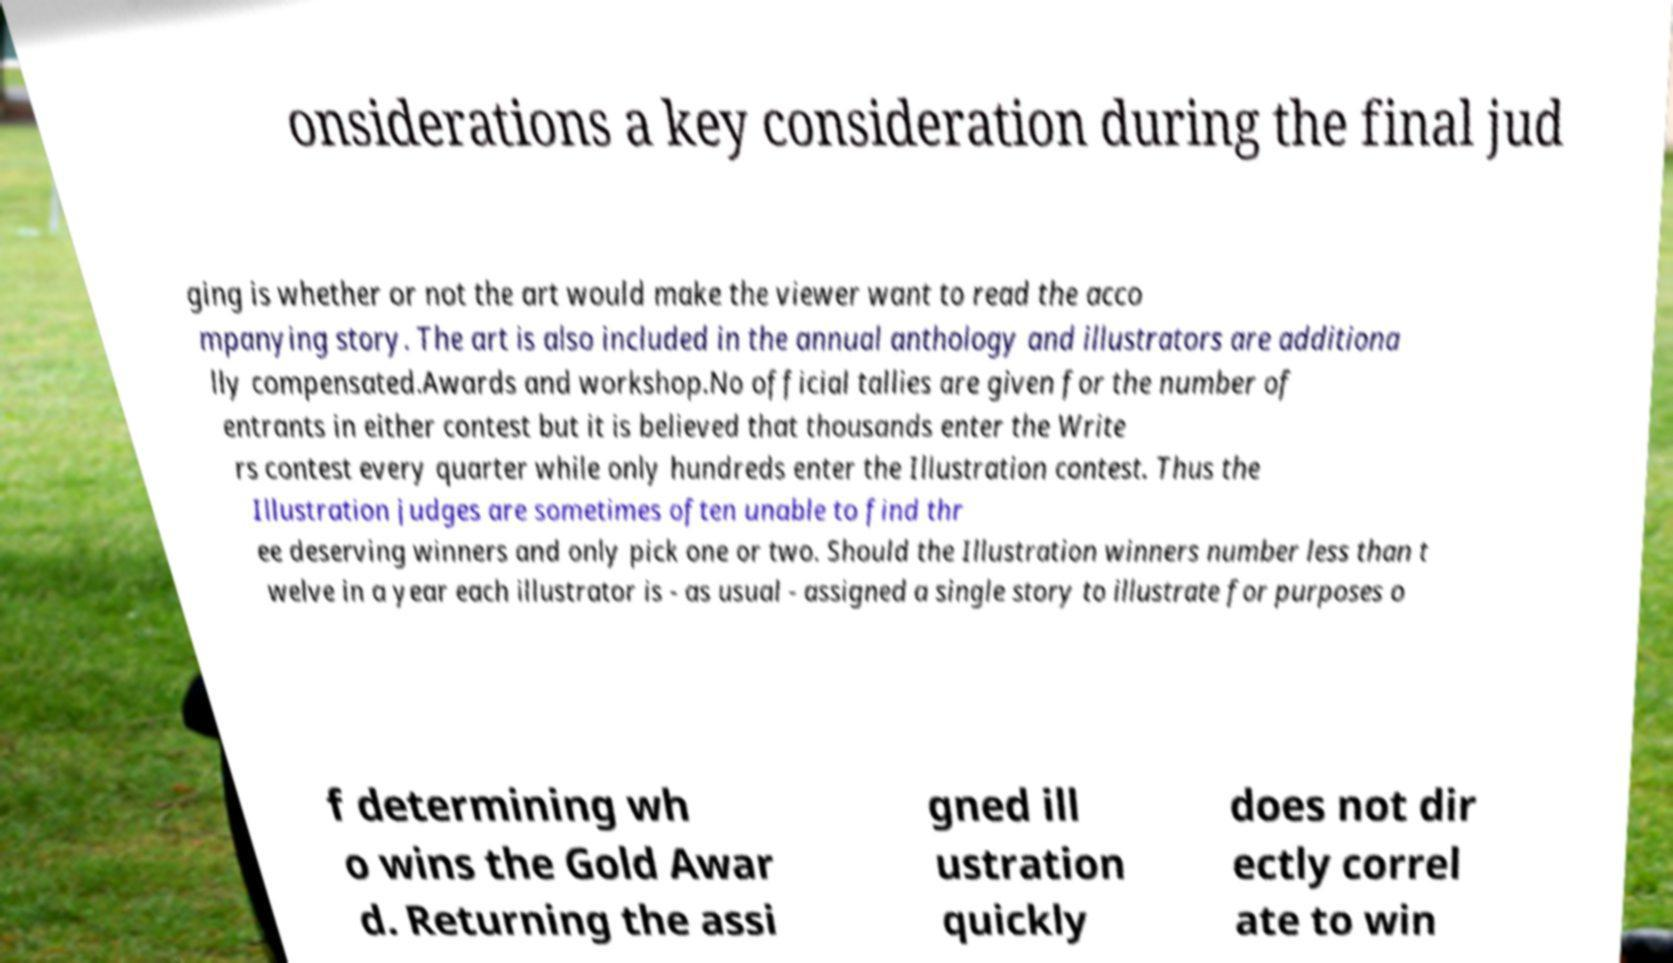I need the written content from this picture converted into text. Can you do that? onsiderations a key consideration during the final jud ging is whether or not the art would make the viewer want to read the acco mpanying story. The art is also included in the annual anthology and illustrators are additiona lly compensated.Awards and workshop.No official tallies are given for the number of entrants in either contest but it is believed that thousands enter the Write rs contest every quarter while only hundreds enter the Illustration contest. Thus the Illustration judges are sometimes often unable to find thr ee deserving winners and only pick one or two. Should the Illustration winners number less than t welve in a year each illustrator is - as usual - assigned a single story to illustrate for purposes o f determining wh o wins the Gold Awar d. Returning the assi gned ill ustration quickly does not dir ectly correl ate to win 